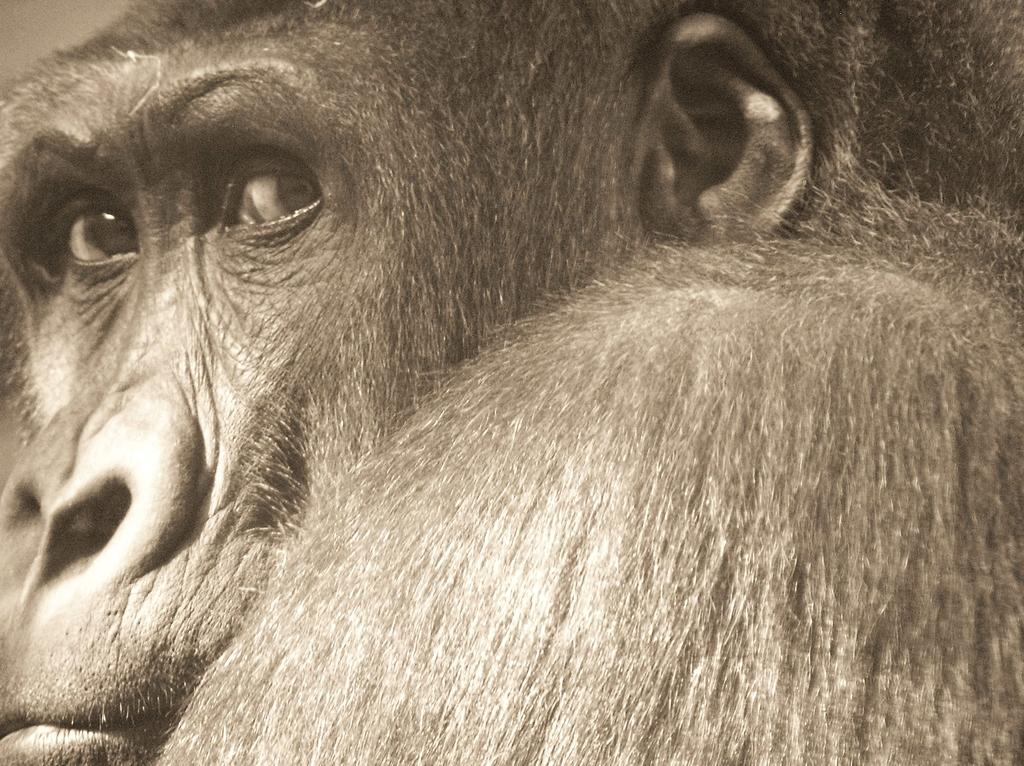What type of animal is in the image? There is a chimpanzee in the image. What advice does the chimpanzee's dad give in the image? There is no mention of a dad or any advice in the image, as it only features a chimpanzee. 